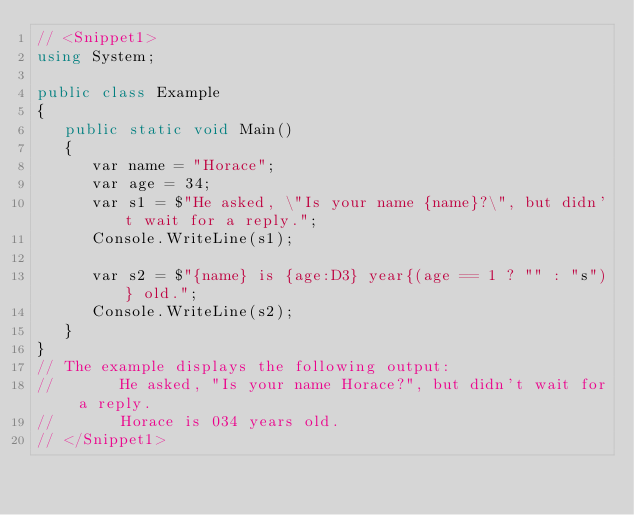Convert code to text. <code><loc_0><loc_0><loc_500><loc_500><_C#_>// <Snippet1>
using System;

public class Example
{
   public static void Main()
   {
      var name = "Horace";
      var age = 34;
      var s1 = $"He asked, \"Is your name {name}?\", but didn't wait for a reply.";
      Console.WriteLine(s1);
      
      var s2 = $"{name} is {age:D3} year{(age == 1 ? "" : "s")} old.";
      Console.WriteLine(s2); 
   }
}
// The example displays the following output:
//       He asked, "Is your name Horace?", but didn't wait for a reply.
//       Horace is 034 years old.
// </Snippet1>
</code> 